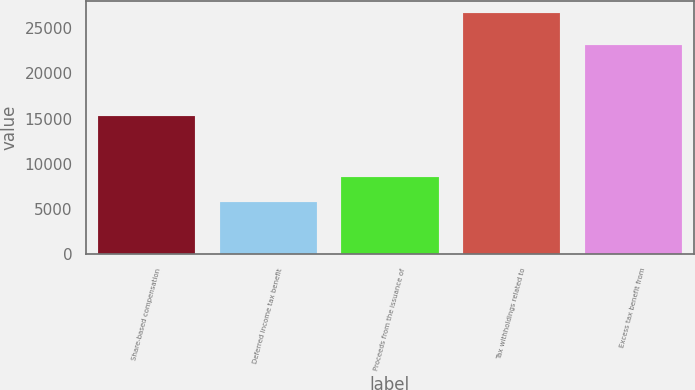<chart> <loc_0><loc_0><loc_500><loc_500><bar_chart><fcel>Share-based compensation<fcel>Deferred income tax benefit<fcel>Proceeds from the issuance of<fcel>Tax withholdings related to<fcel>Excess tax benefit from<nl><fcel>15236<fcel>5774<fcel>8495<fcel>26677<fcel>23099<nl></chart> 